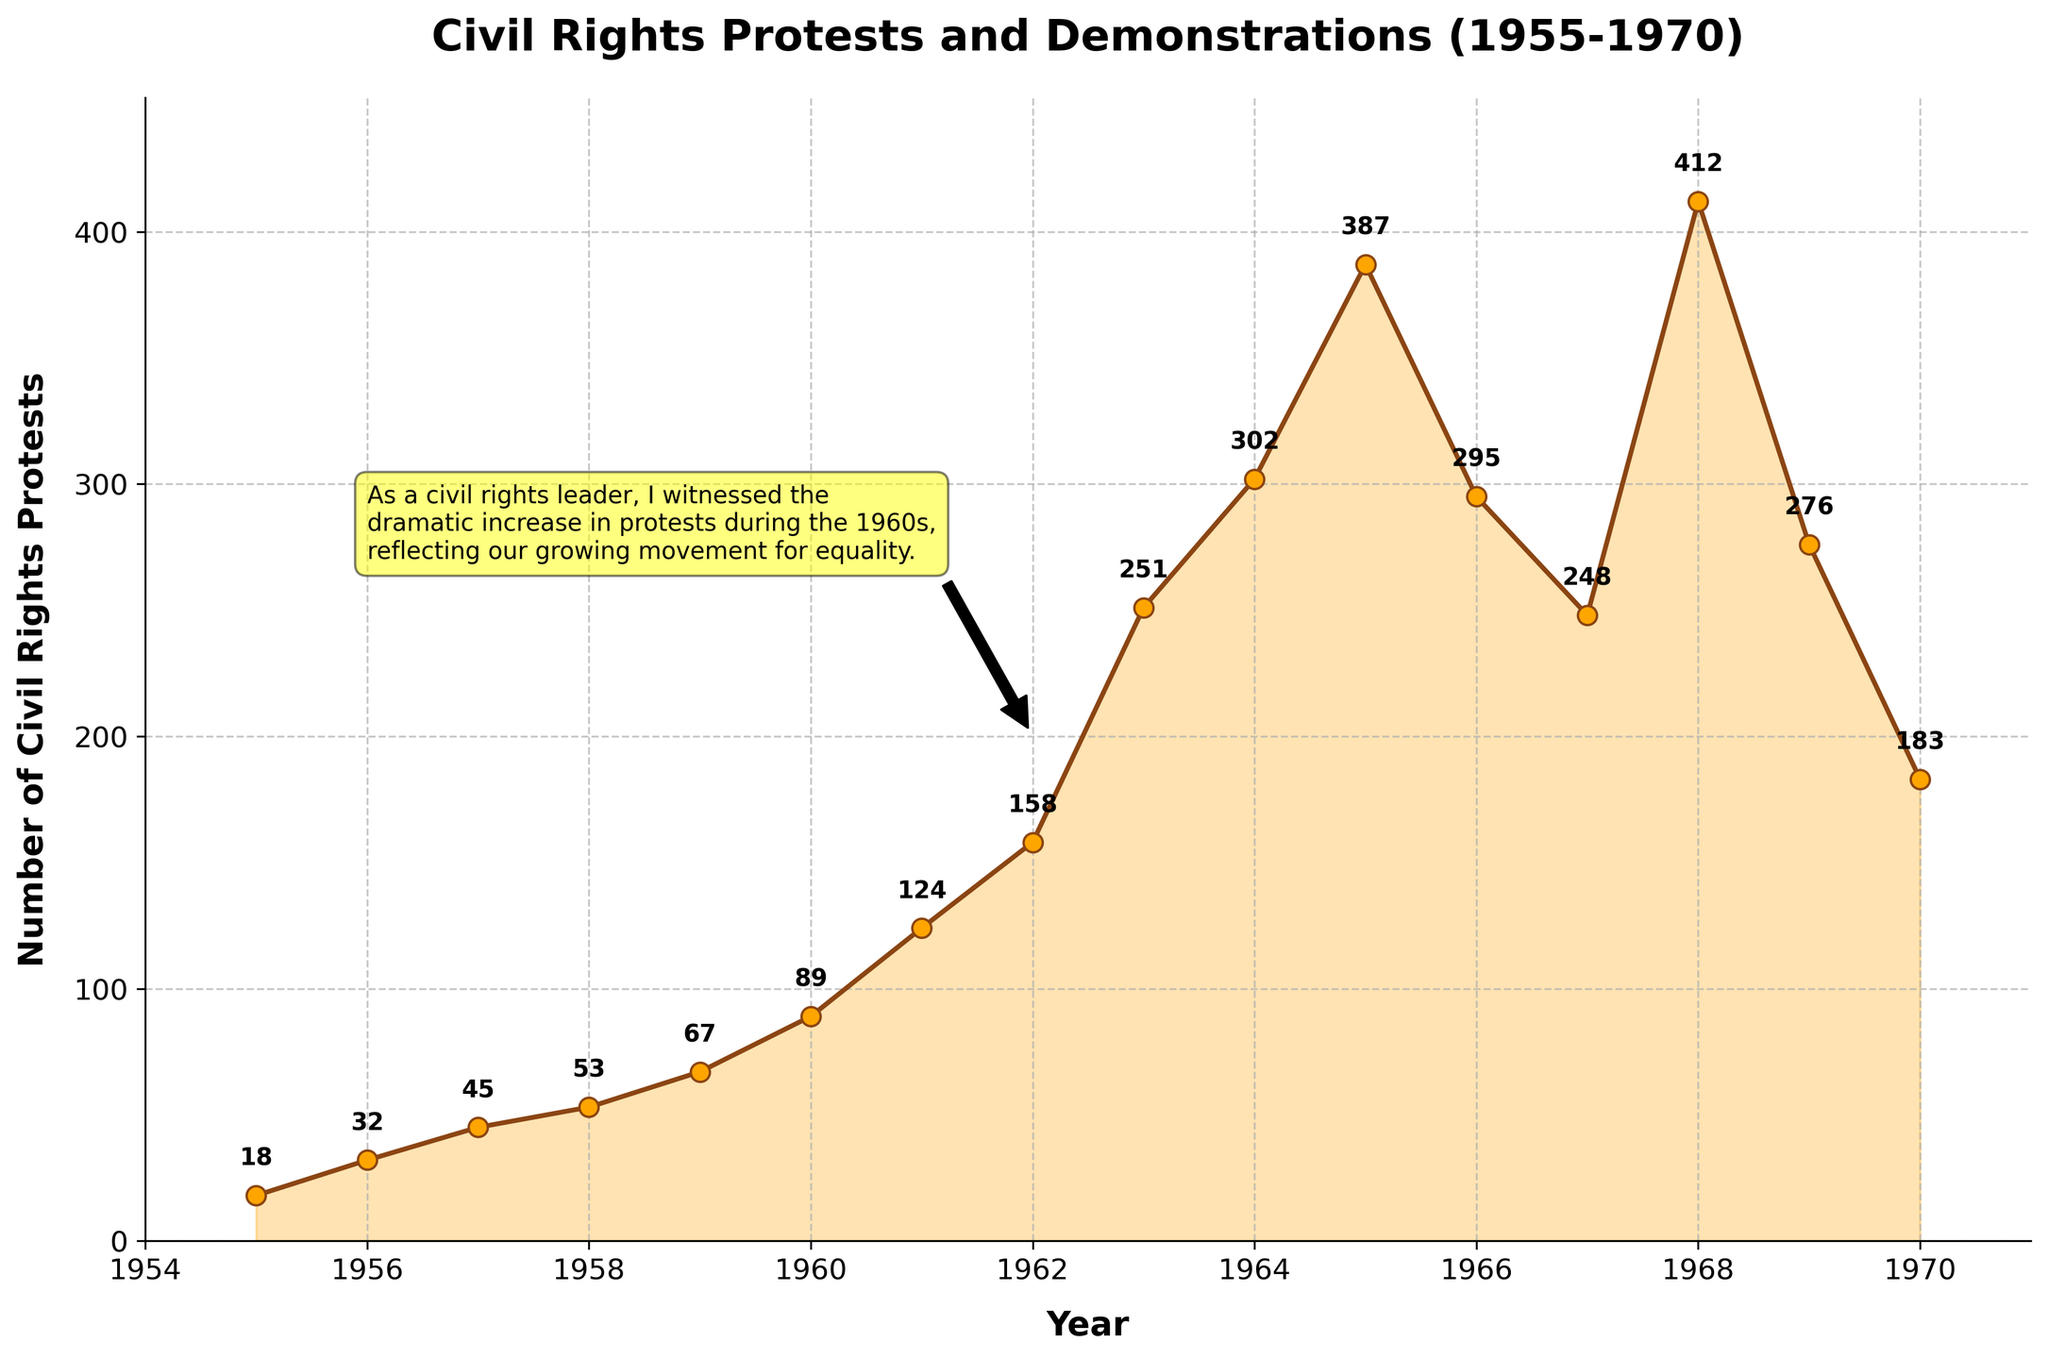What is the year with the highest number of civil rights protests? To identify the year with the highest number of protests, we examine the peak value in the plotted line and its corresponding year. The peak appears in 1968 with 412 protests.
Answer: 1968 What was the approximate increase in civil rights protests between 1955 and 1960? To calculate the increase, we subtract the number of protests in 1955 from the number of protests in 1960: 89 (in 1960) - 18 (in 1955) = 71.
Answer: 71 Which year experienced the largest decrease in civil rights protests compared to the previous year, and what was the magnitude of this decrease? By examining the year-to-year changes, 1966 saw the largest decrease compared to 1965 (387 in 1965 down to 295 in 1966). The magnitude of the decrease is 387 - 295 = 92.
Answer: 1966, 92 What is the average number of protests per year between 1960 and 1965? To find the average, sum up the number of protests from 1960 to 1965 and divide by the number of years: (89 + 124 + 158 + 251 + 302 + 387) / 6 = 85.8.
Answer: 252 Compare the number of protests in 1963 to those in 1970. Which year had more protests, and by how much? By comparing the values, we see that in 1963 there were 251 protests, and in 1970 there were 183. The difference is 251 - 183 = 68. 1963 had 68 more protests than 1970.
Answer: 1963, 68 By how many protests did the number increase from 1962 to 1963? Subtract the number of protests in 1962 from those in 1963: 251 (in 1963) - 158 (in 1962) = 93.
Answer: 93 What is the overall trend in the number of civil rights protests from 1955 to 1970? Observing the plot, we see an overall increasing trend until the mid-1960s with a peak in 1968, followed by a gradual decline towards 1970.
Answer: Increasing then decreasing What was the smallest number of protests recorded in any year, and in which year did it occur? The year with the smallest number of protests was 1955, with 18 protests.
Answer: 1955, 18 What is the approximate increase in the number of protests from 1960 to the peak year? Calculate the increase in protests from 1960 to the peak year of 1968: 412 (in 1968) - 89 (in 1960) = 323.
Answer: 323 